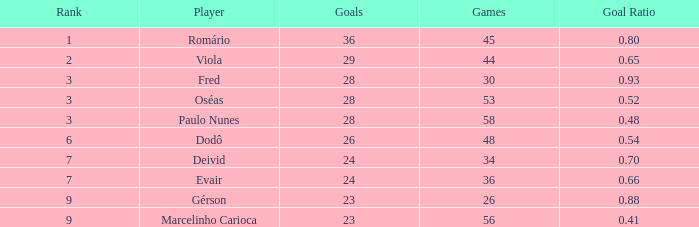How many goal ratios have rank of 2 with more than 44 games? 0.0. 